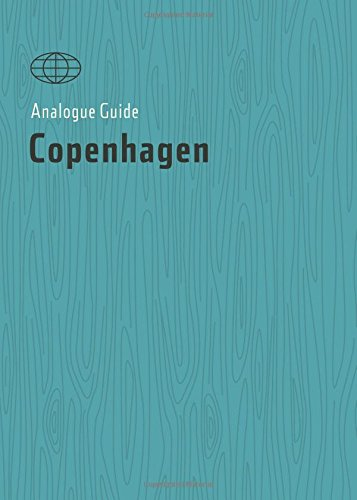Who is the author of this book?
Answer the question using a single word or phrase. Alana Stone What is the title of this book? Analogue Guide Copenhagen (Analogue Guides) What is the genre of this book? Travel Is this book related to Travel? Yes Is this book related to Travel? No 